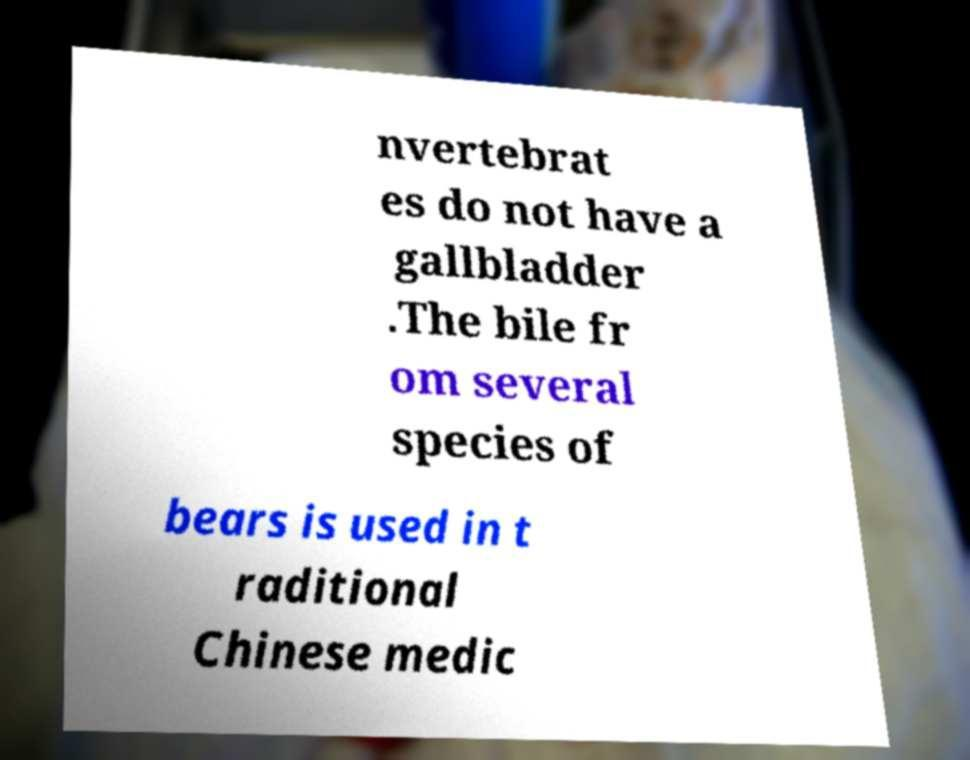What messages or text are displayed in this image? I need them in a readable, typed format. nvertebrat es do not have a gallbladder .The bile fr om several species of bears is used in t raditional Chinese medic 